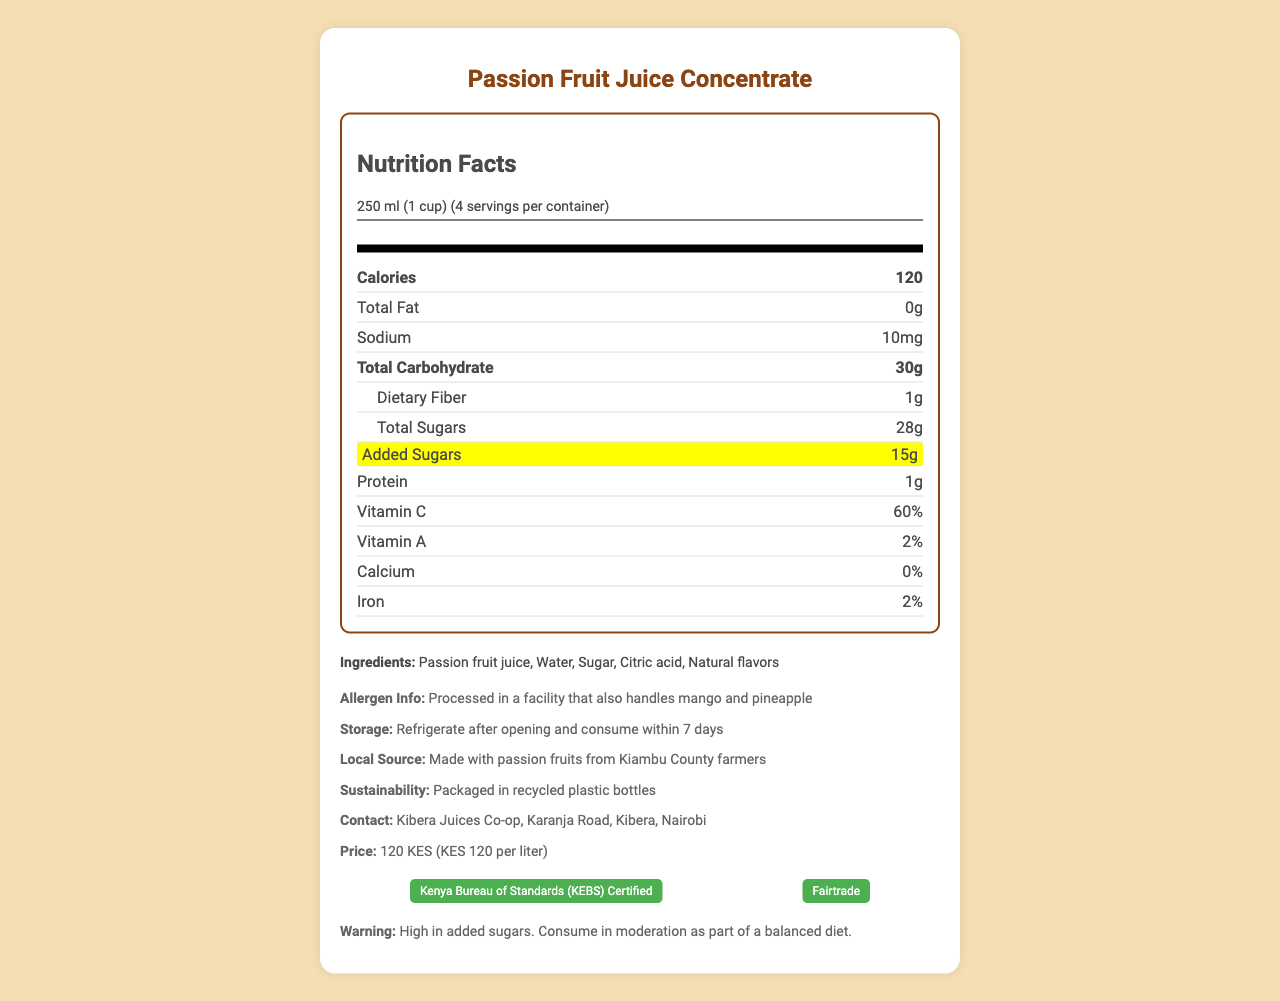what is the serving size? The serving size is mentioned clearly under the "Nutrition Facts" section.
Answer: 250 ml (1 cup) how many calories are in one serving? The document specifies the calories per serving as 120.
Answer: 120 calories what are the ingredients in the juice concentrate? The ingredients are listed under the "Ingredients" section.
Answer: Passion fruit juice, Water, Sugar, Citric acid, Natural flavors how much total carbohydrates are there per serving? The document shows the total carbohydrate content as 30g under the "Nutrition Facts" section.
Answer: 30g what is the sodium content in one serving? The sodium content is listed as 10mg in the nutrients section.
Answer: 10mg which vitamins are present in the juice concentrate? A. Vitamin C and Vitamin A B. Vitamin C and Vitamin D C. Vitamin A and Vitamin D The document lists Vitamin C at 60% and Vitamin A at 2%.
Answer: A what should you do after opening the bottle? These instructions are found under the "Storage" section.
Answer: Refrigerate after opening and consume within 7 days what is the main allergen information provided? The allergen information is clearly mentioned under the "Allergen Info" section.
Answer: Processed in a facility that also handles mango and pineapple what is the price of the juice concentrate in KES? The price information is given at the bottom of the document under "Price."
Answer: 120 KES is this product certified by any organization? The document states that it is "Kenya Bureau of Standards (KEBS) Certified" and "Fairtrade".
Answer: Yes what does the sustainability note mention? The sustainability note specifies that the product is packaged in recycled plastic bottles.
Answer: Packaged in recycled plastic bottles which local source is mentioned for the passion fruits? The local source information specifies that the product uses passion fruits from Kiambu County farmers.
Answer: Kiambu County farmers is the product high in added sugars? The document specifically highlights that it has high added sugars (15g).
Answer: Yes what nutritional claims are highlighted for this juice? These claims are listed under "nutritional claim highlights."
Answer: Good source of Vitamin C, No artificial preservatives, Made from locally sourced fruits does the product contain calcium? The document states that the calcium content is 0%.
Answer: No based on the document, describe the nutrition and additional features of the Passion Fruit Juice Concentrate This summary captures all the key details from the document about nutrition, ingredients, certifications, and additional notes.
Answer: The Passion Fruit Juice Concentrate from Kibera Juices Co-op contains 120 calories per serving (250 ml), with 0g fat, 10mg sodium, 30g carbohydrates (including 28g total sugars and 15g added sugars), 1g protein, and provides 60% of the daily value of Vitamin C and 2% of Vitamin A. It has no calcium and 2% iron. It is made from locally sourced passion fruits from Kiambu County farmers, is packaged in recycled plastic bottles, and is certified by both KEBS and Fairtrade. The product is high in added sugars and should be consumed in moderation. how much protein is in one serving? The protein content is listed as 1g in the nutrients section.
Answer: 1g where is Kibera Juices Co-op located? This contact information is provided at the bottom of the document.
Answer: Karanja Road, Kibera, Nairobi which nutrient has the highest percentage daily value in this product? The document shows that Vitamin C has the highest daily value at 60%.
Answer: Vitamin C how many servings per container are there? A. 2 servings B. 4 servings C. 6 servings The document states there are 4 servings per container.
Answer: B how much added sugar is in one serving? The added sugar content is highlighted in the nutrients section as 15g.
Answer: 15g what type of plastic is used in packaging this juice? The document only mentions that the juice is packaged in recycled plastic bottles but does not specify the type of plastic.
Answer: Cannot be determined 